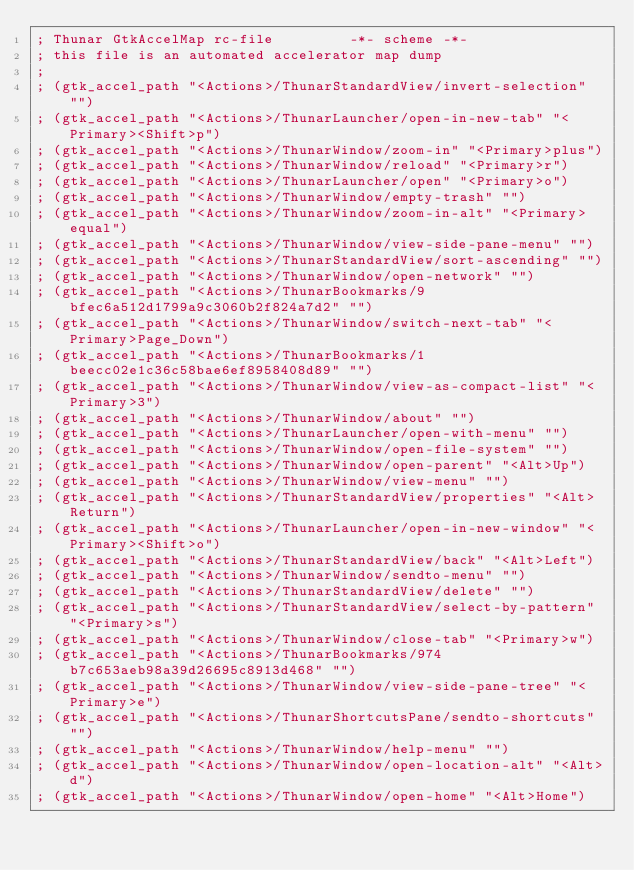Convert code to text. <code><loc_0><loc_0><loc_500><loc_500><_Scheme_>; Thunar GtkAccelMap rc-file         -*- scheme -*-
; this file is an automated accelerator map dump
;
; (gtk_accel_path "<Actions>/ThunarStandardView/invert-selection" "")
; (gtk_accel_path "<Actions>/ThunarLauncher/open-in-new-tab" "<Primary><Shift>p")
; (gtk_accel_path "<Actions>/ThunarWindow/zoom-in" "<Primary>plus")
; (gtk_accel_path "<Actions>/ThunarWindow/reload" "<Primary>r")
; (gtk_accel_path "<Actions>/ThunarLauncher/open" "<Primary>o")
; (gtk_accel_path "<Actions>/ThunarWindow/empty-trash" "")
; (gtk_accel_path "<Actions>/ThunarWindow/zoom-in-alt" "<Primary>equal")
; (gtk_accel_path "<Actions>/ThunarWindow/view-side-pane-menu" "")
; (gtk_accel_path "<Actions>/ThunarStandardView/sort-ascending" "")
; (gtk_accel_path "<Actions>/ThunarWindow/open-network" "")
; (gtk_accel_path "<Actions>/ThunarBookmarks/9bfec6a512d1799a9c3060b2f824a7d2" "")
; (gtk_accel_path "<Actions>/ThunarWindow/switch-next-tab" "<Primary>Page_Down")
; (gtk_accel_path "<Actions>/ThunarBookmarks/1beecc02e1c36c58bae6ef8958408d89" "")
; (gtk_accel_path "<Actions>/ThunarWindow/view-as-compact-list" "<Primary>3")
; (gtk_accel_path "<Actions>/ThunarWindow/about" "")
; (gtk_accel_path "<Actions>/ThunarLauncher/open-with-menu" "")
; (gtk_accel_path "<Actions>/ThunarWindow/open-file-system" "")
; (gtk_accel_path "<Actions>/ThunarWindow/open-parent" "<Alt>Up")
; (gtk_accel_path "<Actions>/ThunarWindow/view-menu" "")
; (gtk_accel_path "<Actions>/ThunarStandardView/properties" "<Alt>Return")
; (gtk_accel_path "<Actions>/ThunarLauncher/open-in-new-window" "<Primary><Shift>o")
; (gtk_accel_path "<Actions>/ThunarStandardView/back" "<Alt>Left")
; (gtk_accel_path "<Actions>/ThunarWindow/sendto-menu" "")
; (gtk_accel_path "<Actions>/ThunarStandardView/delete" "")
; (gtk_accel_path "<Actions>/ThunarStandardView/select-by-pattern" "<Primary>s")
; (gtk_accel_path "<Actions>/ThunarWindow/close-tab" "<Primary>w")
; (gtk_accel_path "<Actions>/ThunarBookmarks/974b7c653aeb98a39d26695c8913d468" "")
; (gtk_accel_path "<Actions>/ThunarWindow/view-side-pane-tree" "<Primary>e")
; (gtk_accel_path "<Actions>/ThunarShortcutsPane/sendto-shortcuts" "")
; (gtk_accel_path "<Actions>/ThunarWindow/help-menu" "")
; (gtk_accel_path "<Actions>/ThunarWindow/open-location-alt" "<Alt>d")
; (gtk_accel_path "<Actions>/ThunarWindow/open-home" "<Alt>Home")</code> 